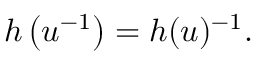Convert formula to latex. <formula><loc_0><loc_0><loc_500><loc_500>h \left ( u ^ { - 1 } \right ) = h ( u ) ^ { - 1 } .</formula> 